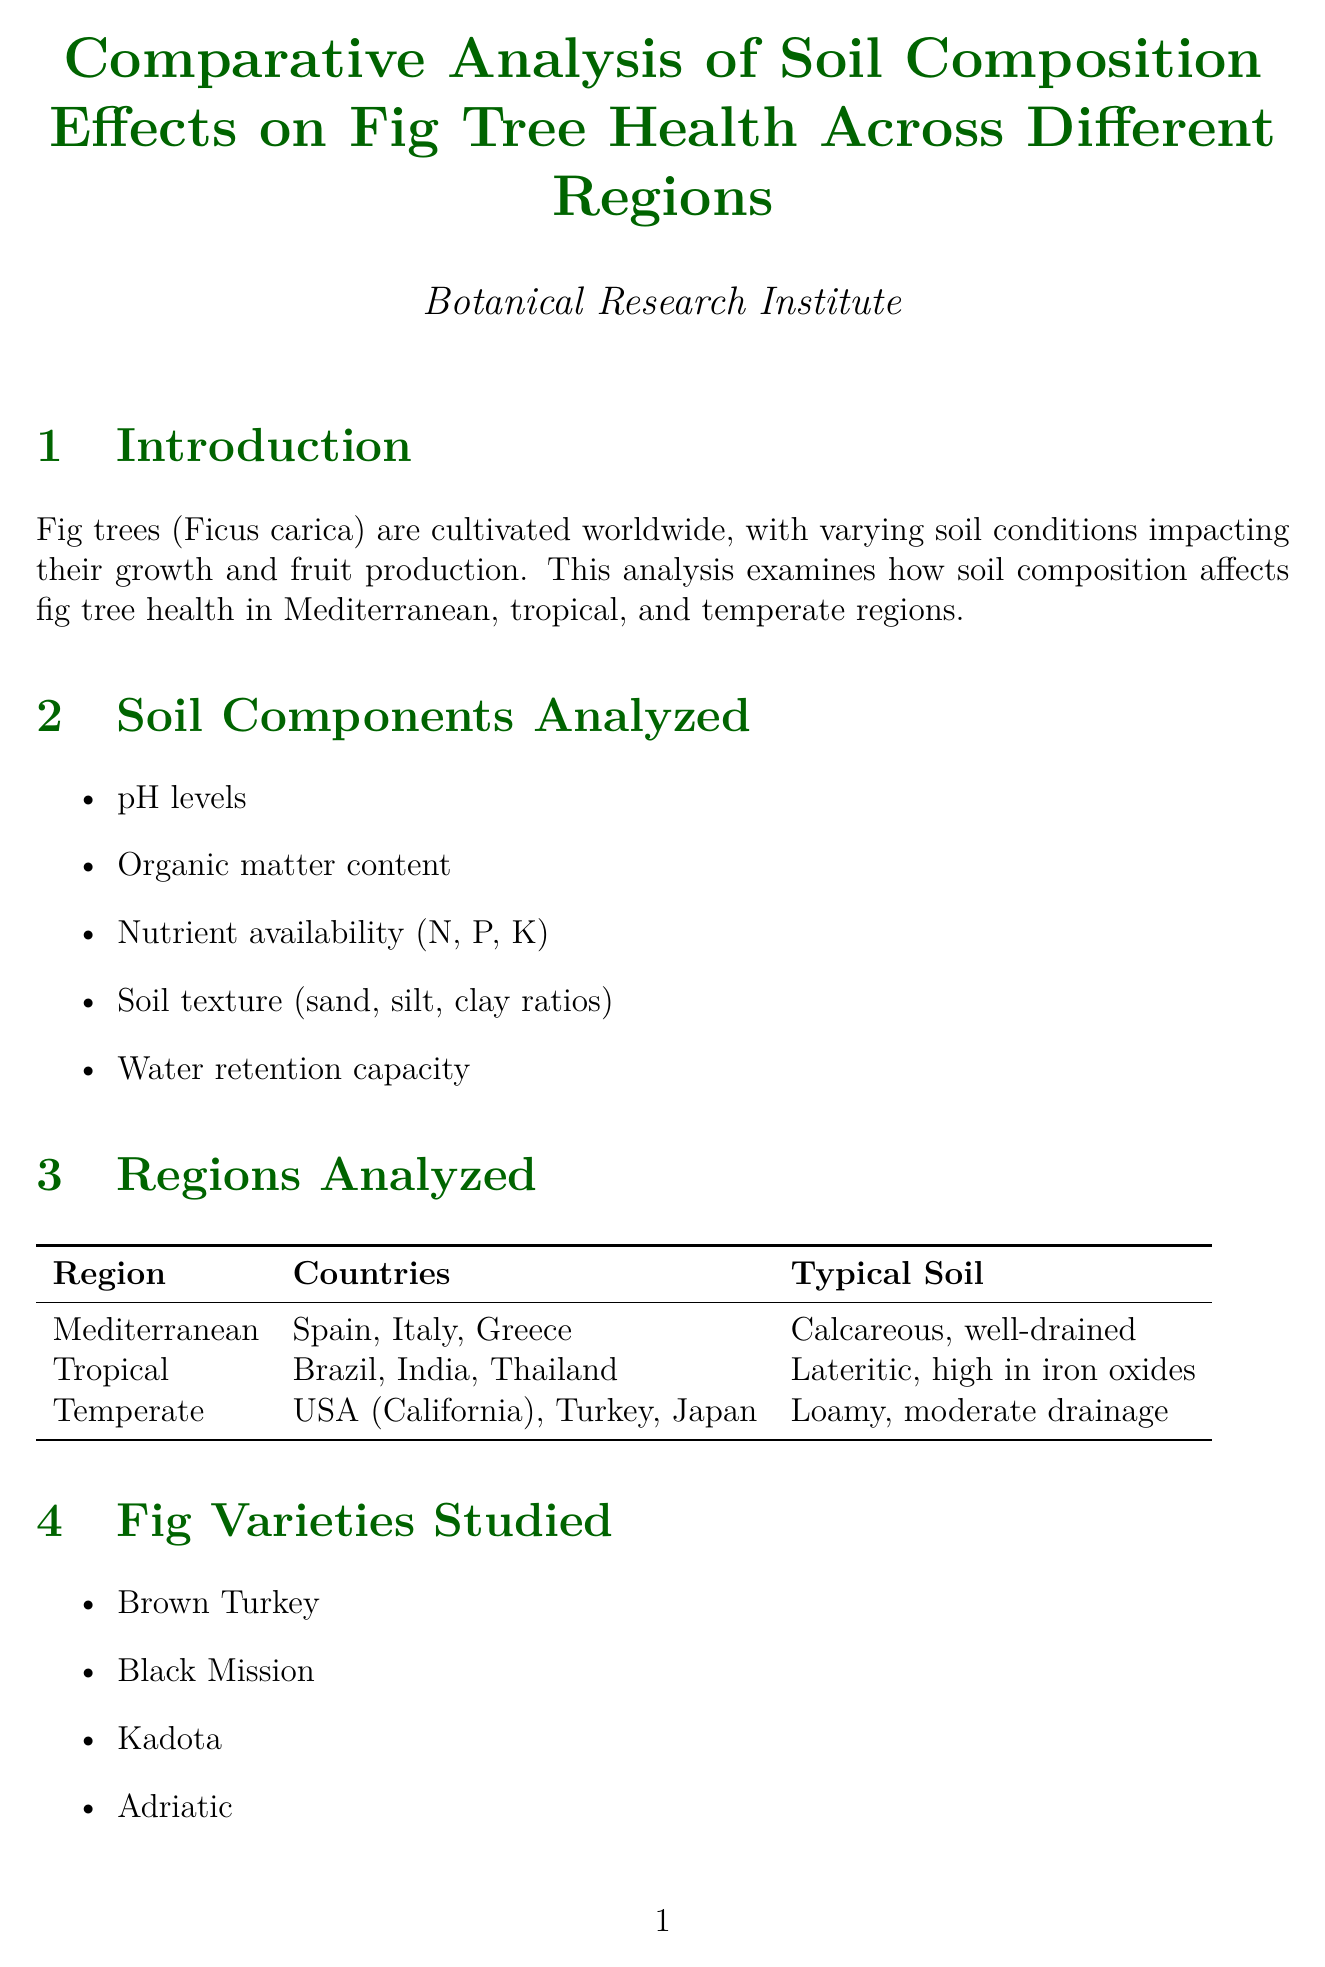What are the regions analyzed in the report? The regions analyzed in the report include Mediterranean, tropical, and temperate regions.
Answer: Mediterranean, tropical, and temperate What is the best performing fig variety in the Mediterranean region? The best performing fig variety in the Mediterranean region is noted in the key findings.
Answer: Adriatic What soil type is typical for the tropical region? The typical soil type for the tropical region is mentioned in the regions analyzed section.
Answer: Lateritic, high in iron oxides Which method is used for nutrient analysis? The method for nutrient analysis is found in the soil analysis methods section of the document.
Answer: Inductively coupled plasma mass spectrometry (ICP-MS) What is the optimal soil pH for fig trees in the tropical region? The optimal soil pH for fig trees in the tropical region is stated in the key findings.
Answer: 6.0 - 7.0 What amendment is recommended for high pH in calcareous soils? The recommendation for high pH in calcareous soils can be found in the soil amendment recommendations.
Answer: Application of elemental sulfur or aluminum sulfate What future research direction is suggested related to climate change? Future research directions include potential research on climate change effects mentioned in the document.
Answer: Impact of climate change on soil composition and fig cultivation What is one notable observation from the tropical region? A notable observation from the tropical region is provided in the key findings section.
Answer: Addition of organic matter significantly improved water retention in sandy soils 